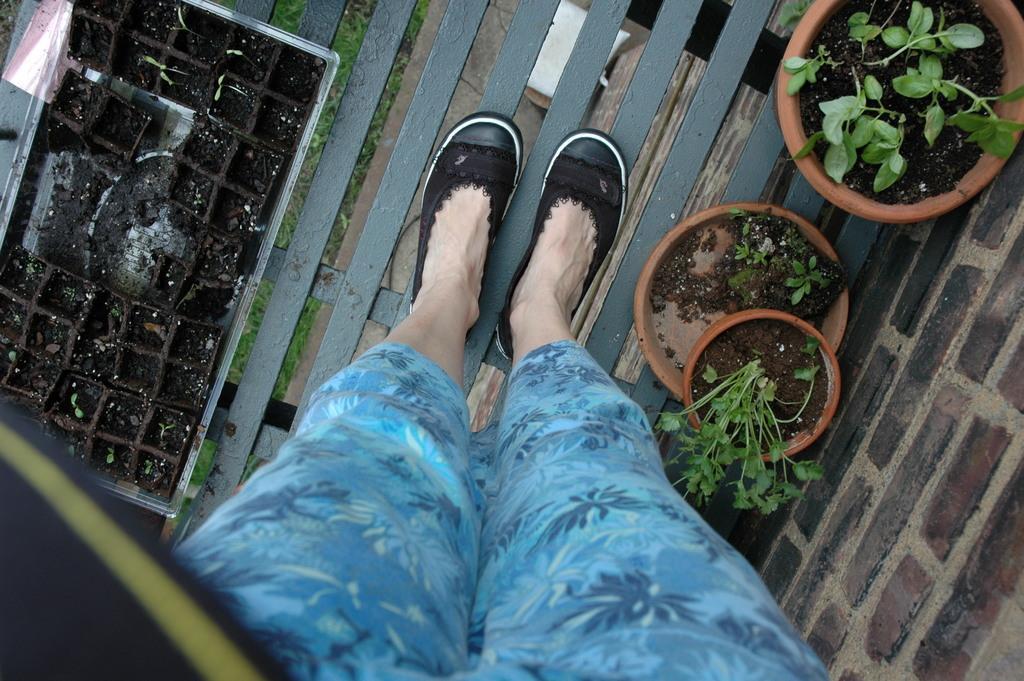Please provide a concise description of this image. In this picture we can see legs of a person, beside the person we can find few plants in the flower pots. 